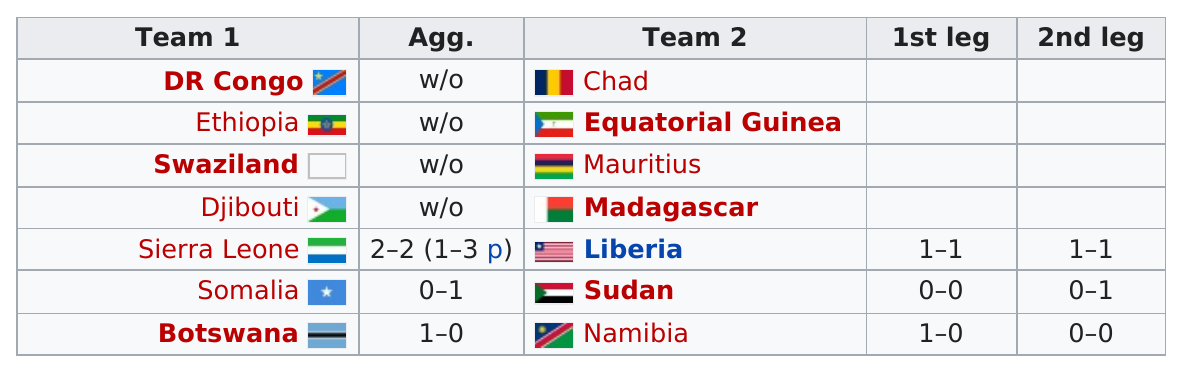Draw attention to some important aspects in this diagram. There are 14 countries participating in the preliminary qualifying round. There are at least four teams in the column of team 2, and they are alive. After DR Congo, the next team is Ethiopia. Six teams, including Sierra Leone, Liberia, Somalia, Sudan, Botswana, and Namibia, participated in the first leg of the 2011 CAF U-23 Championship qualification. Team Somalia is before Team Botswana in Column Team 1. 